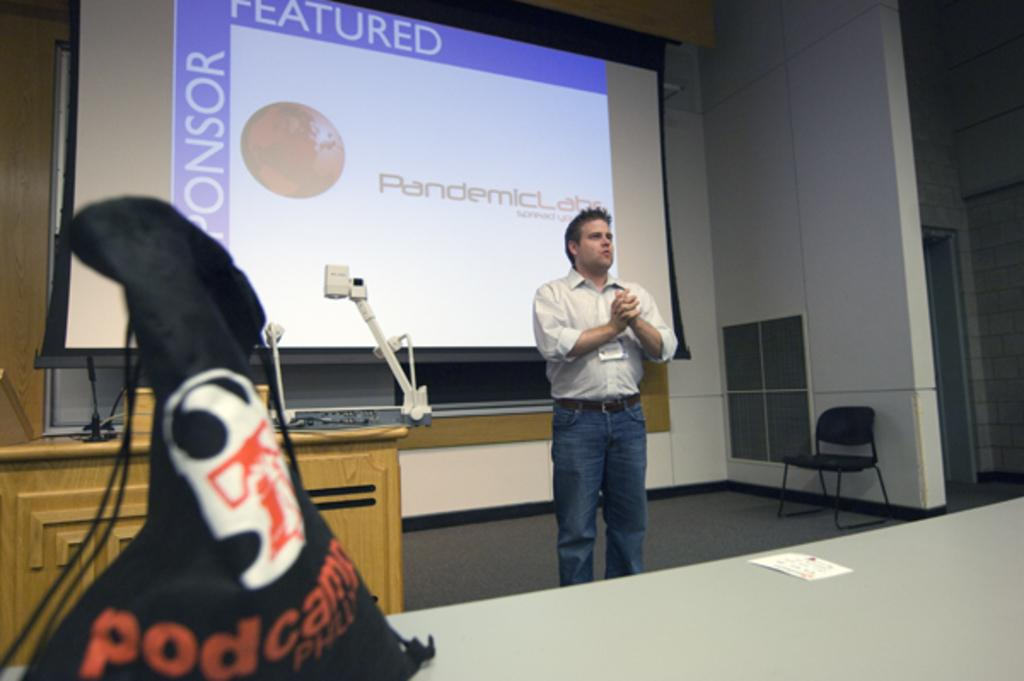What is the man in the image doing? The man is talking in the image. What can be seen in the background of the image? There is a table, a mic, and a screen in the background of the image. What is present in the foreground of the image? There is a bag on the table in the foreground of the image. What type of furniture is in the image? There is a chair in the image. What type of copper spoon is visible in the image? There is no copper spoon present in the image. What is the jar used for in the image? There is no jar present in the image. 